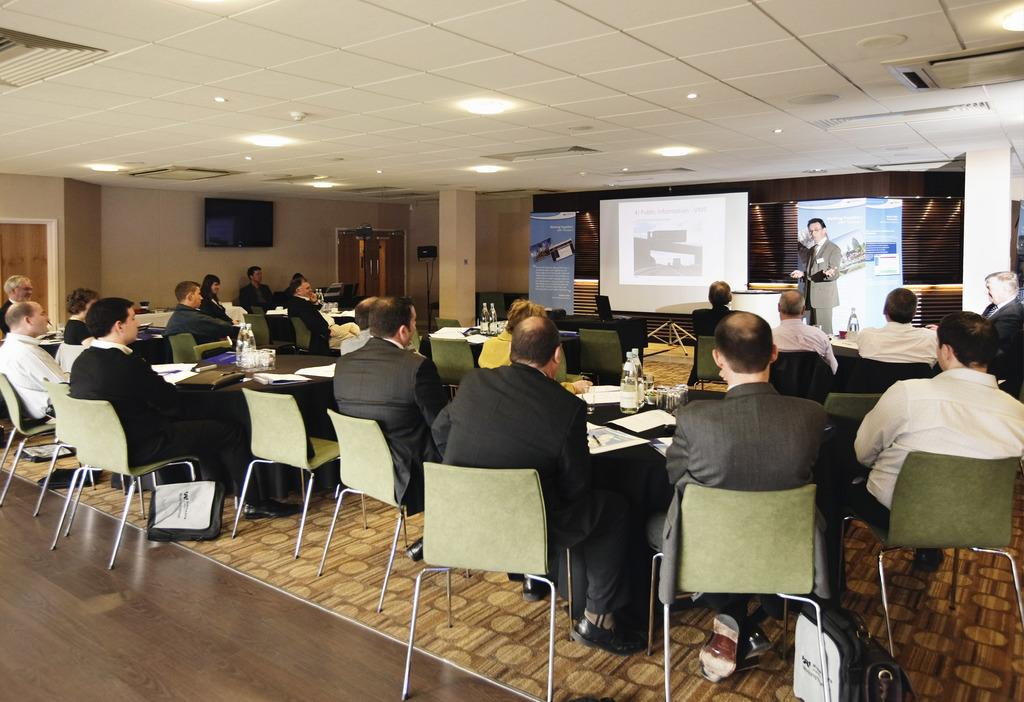What are the people in the image doing? There is a group of people sitting on chairs in the image. Is there anyone standing in the image? Yes, one person is standing in front of the group. What can be seen next to the standing person? There is a screen to the side of the standing person. What else is present in the image? There is a banner in the image. What type of pen is being used to draw on the banner in the image? There is no pen or drawing activity present in the image; it only shows a group of people sitting on chairs, a standing person, a screen, and a banner. 